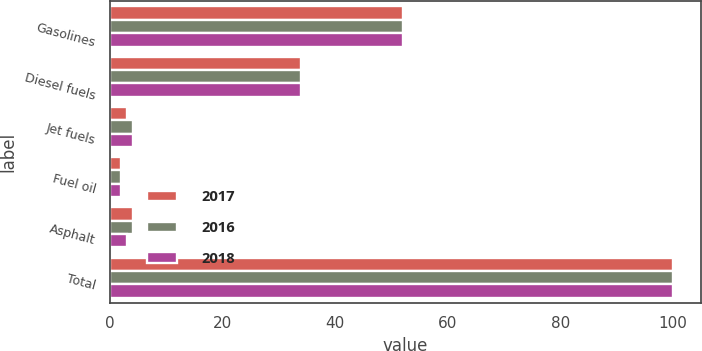<chart> <loc_0><loc_0><loc_500><loc_500><stacked_bar_chart><ecel><fcel>Gasolines<fcel>Diesel fuels<fcel>Jet fuels<fcel>Fuel oil<fcel>Asphalt<fcel>Total<nl><fcel>2017<fcel>52<fcel>34<fcel>3<fcel>2<fcel>4<fcel>100<nl><fcel>2016<fcel>52<fcel>34<fcel>4<fcel>2<fcel>4<fcel>100<nl><fcel>2018<fcel>52<fcel>34<fcel>4<fcel>2<fcel>3<fcel>100<nl></chart> 